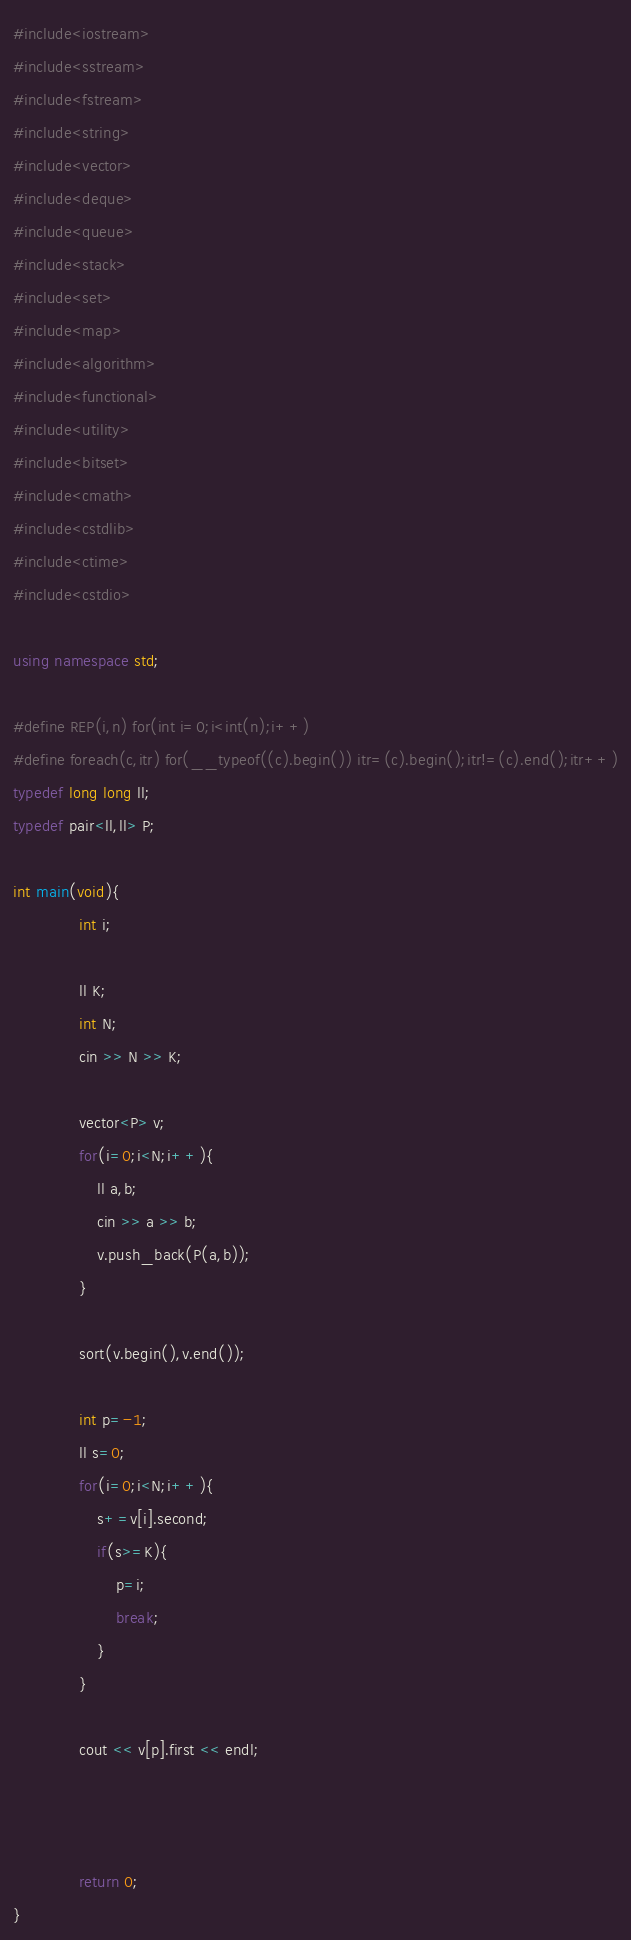<code> <loc_0><loc_0><loc_500><loc_500><_C++_>#include<iostream>
#include<sstream>
#include<fstream>
#include<string>
#include<vector>
#include<deque>
#include<queue>
#include<stack>
#include<set>
#include<map>
#include<algorithm>
#include<functional>
#include<utility>
#include<bitset>
#include<cmath>
#include<cstdlib>
#include<ctime>
#include<cstdio>

using namespace std;

#define REP(i,n) for(int i=0;i<int(n);i++)
#define foreach(c,itr) for(__typeof((c).begin()) itr=(c).begin();itr!=(c).end();itr++)
typedef long long ll;
typedef pair<ll,ll> P;

int main(void){
	          int i;

	          ll K;
	          int N;
	          cin >> N >> K;

	          vector<P> v;
	          for(i=0;i<N;i++){
	        	  ll a,b;
	        	  cin >> a >> b;
	        	  v.push_back(P(a,b));
	          }

	          sort(v.begin(),v.end());

	          int p=-1;
	          ll s=0;
	          for(i=0;i<N;i++){
	        	  s+=v[i].second;
	        	  if(s>=K){
	        		  p=i;
	        		  break;
	        	  }
	          }

	          cout << v[p].first << endl;



	          return 0;
}
</code> 